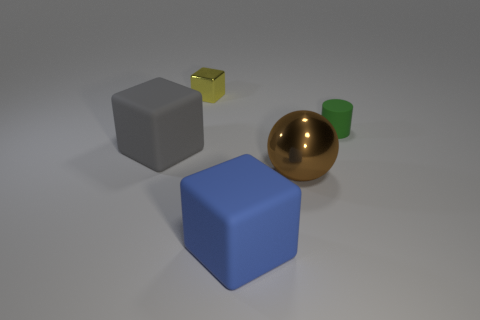Is the number of cubes on the right side of the large brown sphere less than the number of tiny metallic objects?
Make the answer very short. Yes. The matte cylinder is what color?
Keep it short and to the point. Green. There is another large rubber thing that is the same shape as the big gray thing; what color is it?
Your answer should be very brief. Blue. How many big things are either red matte objects or yellow metallic things?
Offer a terse response. 0. How big is the metallic thing that is in front of the yellow shiny thing?
Give a very brief answer. Large. There is a matte object to the left of the yellow metal cube; what number of rubber objects are behind it?
Keep it short and to the point. 1. How many other green things are the same material as the small green thing?
Keep it short and to the point. 0. Are there any cubes on the left side of the blue rubber block?
Offer a terse response. Yes. What is the color of the other rubber cube that is the same size as the gray cube?
Your answer should be compact. Blue. How many things are blue blocks right of the gray block or big gray cylinders?
Offer a very short reply. 1. 